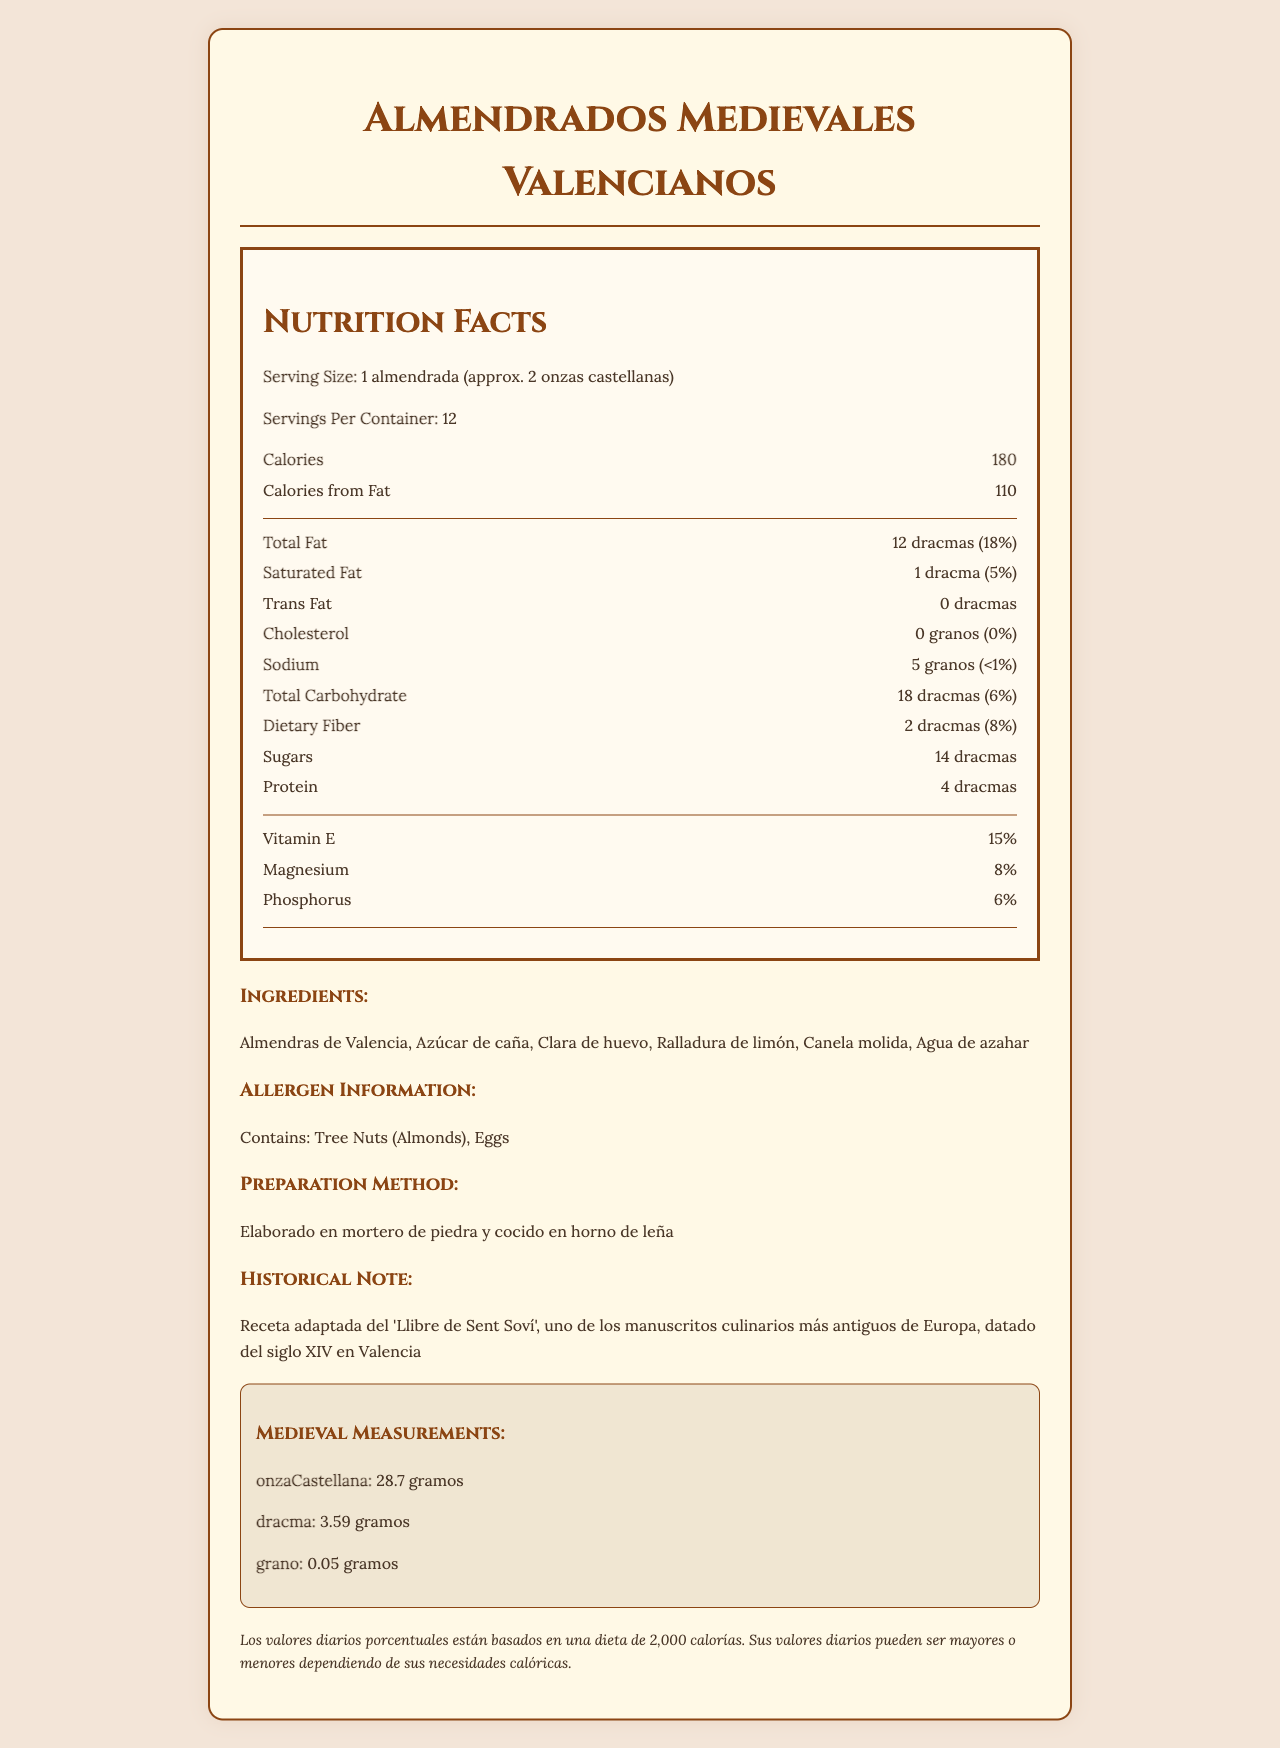what is the product name? The product name is prominently displayed at the top of the document, titled "Almendrados Medievales Valencianos."
Answer: Almendrados Medievales Valencianos what is the serving size? The serving size is listed right under the "Nutrition Facts" section as "1 almendrada (approx. 2 onzas castellanas)."
Answer: 1 almendrada (approx. 2 onzas castellanas) how many servings are in the container? The number of servings per container is specified as 12 in the "Nutrition Facts" section.
Answer: 12 what are the total calories per serving? The document states that each serving contains 180 calories.
Answer: 180 what are the ingredients of this product? The ingredient list is provided in the section titled "Ingredients."
Answer: Almendras de Valencia, Azúcar de caña, Clara de huevo, Ralladura de limón, Canela molida, Agua de azahar does this product contain any allergens? The "Allergen Information" section states that the product contains tree nuts (almonds) and eggs.
Answer: Yes how is this dessert prepared? The preparation method is detailed in the "Preparation Method" section as "Elaborado en mortero de piedra y cocido en horno de leña."
Answer: Elaborado en mortero de piedra y cocido en horno de leña based on the nutrition facts, how much total fat does one serving contain? The "Total Fat" content per serving is listed as 12 dracmas.
Answer: 12 dracmas what ancient manuscript is the recipe adapted from? The "Historical Note" mentions that the recipe is adapted from the 'Llibre de Sent Soví'.
Answer: 'Llibre de Sent Soví' is there any cholesterol in a serving of this dessert? The "Cholesterol" section states that there is 0 granos of cholesterol per serving.
Answer: No which of the following nutrients is not listed in the vitamins/minerals section? A. Vitamin E B. Vitamin C C. Magnesium Vitamin C is not listed; only Vitamin E, Magnesium, and Phosphorus are mentioned.
Answer: B what is the daily value percentage of dietary fiber in one serving? A. 5% B. 8% C. 15% The daily value percentage for dietary fiber is listed as 8%.
Answer: B is the total carbohydrate amount per serving more than 15 dracmas? The "Total Carbohydrate" amount is listed as 18 dracmas, which is more than 15 dracmas.
Answer: Yes describe the main idea of the document The document provides comprehensive information on Almendrados Medievales Valencianos, including its nutritional content, ingredients, how it is prepared, and its historical roots, using a layout that incorporates ancient measurements such as onza castellana, dracma, and grano.
Answer: The document details the nutrition facts, ingredients, preparation method, historical note, and allergen information for a medieval Valencian almond-based dessert called Almendrados Medievales Valencianos, featuring ancient measurements and cooking techniques. what is the exact weight in grams of 1 onza castellana? According to the "Medieval Measurements" section, 1 onza castellana equals 28.7 grams.
Answer: 28.7 grams how many grams of protein are in one serving? The document lists protein content as 4 dracmas, but without the conversion to grams, it cannot be determined directly from the visual information.
Answer: Cannot be determined what is the preparation method for the dessert? This is specified in the "Preparation Method" section of the document.
Answer: Elaborado en mortero de piedra y cocido en horno de leña 